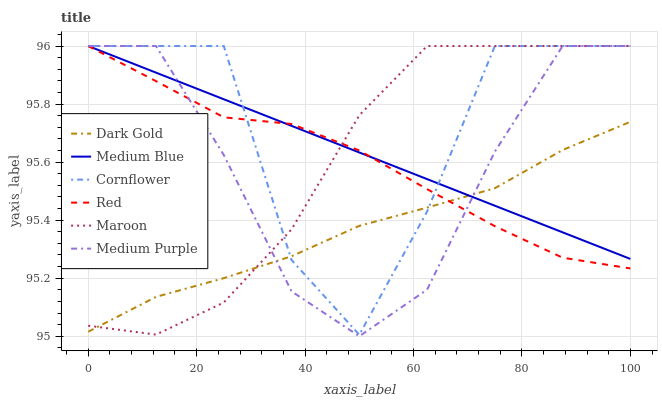Does Dark Gold have the minimum area under the curve?
Answer yes or no. Yes. Does Cornflower have the maximum area under the curve?
Answer yes or no. Yes. Does Medium Blue have the minimum area under the curve?
Answer yes or no. No. Does Medium Blue have the maximum area under the curve?
Answer yes or no. No. Is Medium Blue the smoothest?
Answer yes or no. Yes. Is Cornflower the roughest?
Answer yes or no. Yes. Is Dark Gold the smoothest?
Answer yes or no. No. Is Dark Gold the roughest?
Answer yes or no. No. Does Dark Gold have the lowest value?
Answer yes or no. No. Does Red have the highest value?
Answer yes or no. Yes. Does Dark Gold have the highest value?
Answer yes or no. No. Does Medium Blue intersect Red?
Answer yes or no. Yes. Is Medium Blue less than Red?
Answer yes or no. No. Is Medium Blue greater than Red?
Answer yes or no. No. 